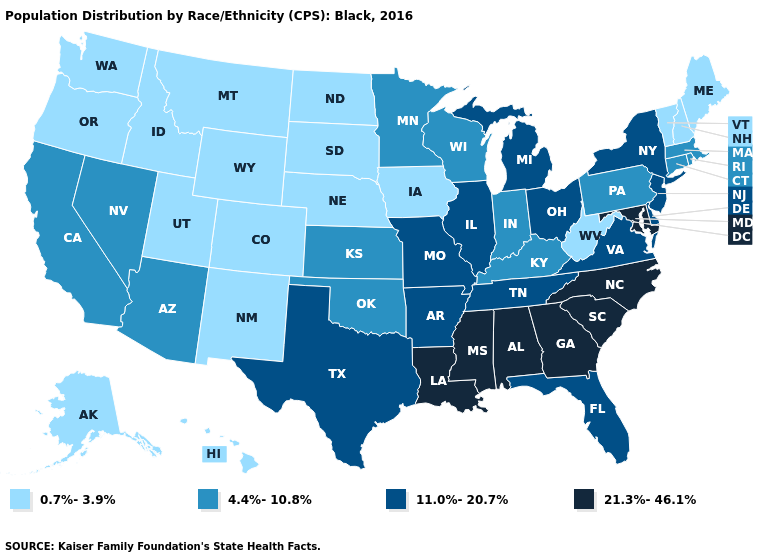What is the lowest value in the USA?
Short answer required. 0.7%-3.9%. Does Kentucky have the same value as Maine?
Answer briefly. No. What is the lowest value in the USA?
Give a very brief answer. 0.7%-3.9%. What is the highest value in the South ?
Answer briefly. 21.3%-46.1%. What is the value of Iowa?
Answer briefly. 0.7%-3.9%. Name the states that have a value in the range 0.7%-3.9%?
Give a very brief answer. Alaska, Colorado, Hawaii, Idaho, Iowa, Maine, Montana, Nebraska, New Hampshire, New Mexico, North Dakota, Oregon, South Dakota, Utah, Vermont, Washington, West Virginia, Wyoming. Name the states that have a value in the range 21.3%-46.1%?
Keep it brief. Alabama, Georgia, Louisiana, Maryland, Mississippi, North Carolina, South Carolina. Does Vermont have the lowest value in the Northeast?
Quick response, please. Yes. What is the lowest value in states that border Alabama?
Short answer required. 11.0%-20.7%. Name the states that have a value in the range 4.4%-10.8%?
Short answer required. Arizona, California, Connecticut, Indiana, Kansas, Kentucky, Massachusetts, Minnesota, Nevada, Oklahoma, Pennsylvania, Rhode Island, Wisconsin. What is the value of Oregon?
Give a very brief answer. 0.7%-3.9%. What is the value of Kansas?
Quick response, please. 4.4%-10.8%. What is the value of Georgia?
Be succinct. 21.3%-46.1%. What is the value of Maine?
Quick response, please. 0.7%-3.9%. Name the states that have a value in the range 21.3%-46.1%?
Keep it brief. Alabama, Georgia, Louisiana, Maryland, Mississippi, North Carolina, South Carolina. 